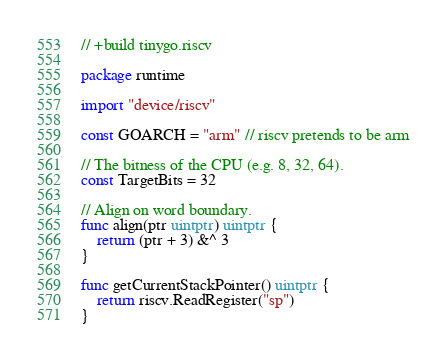<code> <loc_0><loc_0><loc_500><loc_500><_Go_>// +build tinygo.riscv

package runtime

import "device/riscv"

const GOARCH = "arm" // riscv pretends to be arm

// The bitness of the CPU (e.g. 8, 32, 64).
const TargetBits = 32

// Align on word boundary.
func align(ptr uintptr) uintptr {
	return (ptr + 3) &^ 3
}

func getCurrentStackPointer() uintptr {
	return riscv.ReadRegister("sp")
}
</code> 